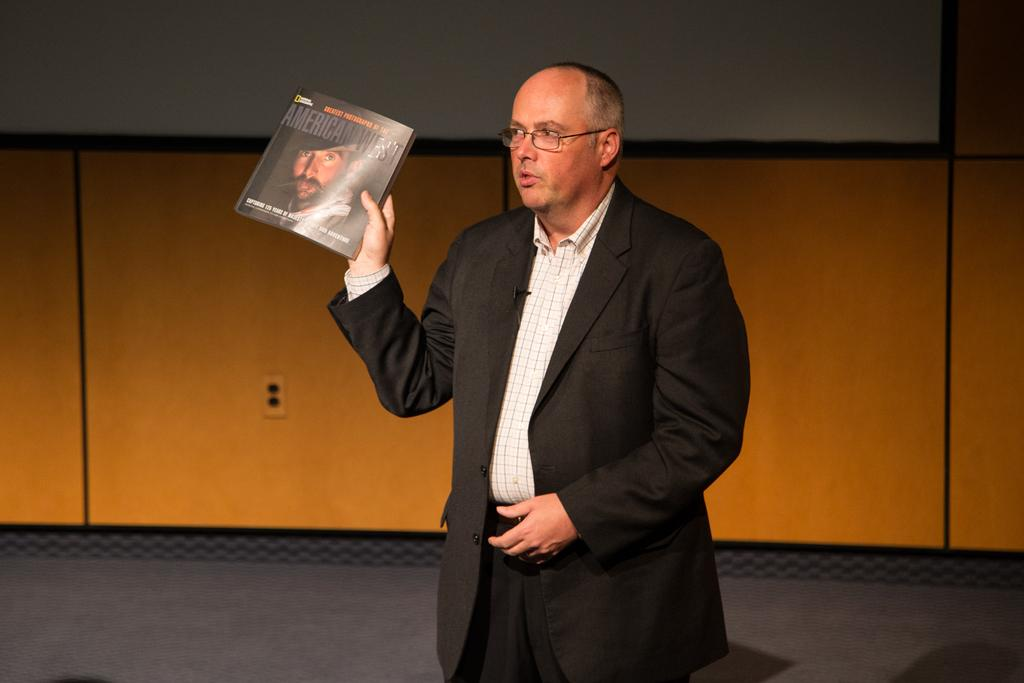Who is present in the image? There is a man in the image. What is the man wearing? The man is wearing a suit. Where is the man located in the image? The man is standing on a stage. What is the man holding in his hand? The man is holding a book in his hand. What can be seen in the background of the image? There is a wooden wall and a screen attached to it in the background of the image. What type of list is the beggar holding in the image? There is no beggar present in the image, and therefore no list can be observed. 